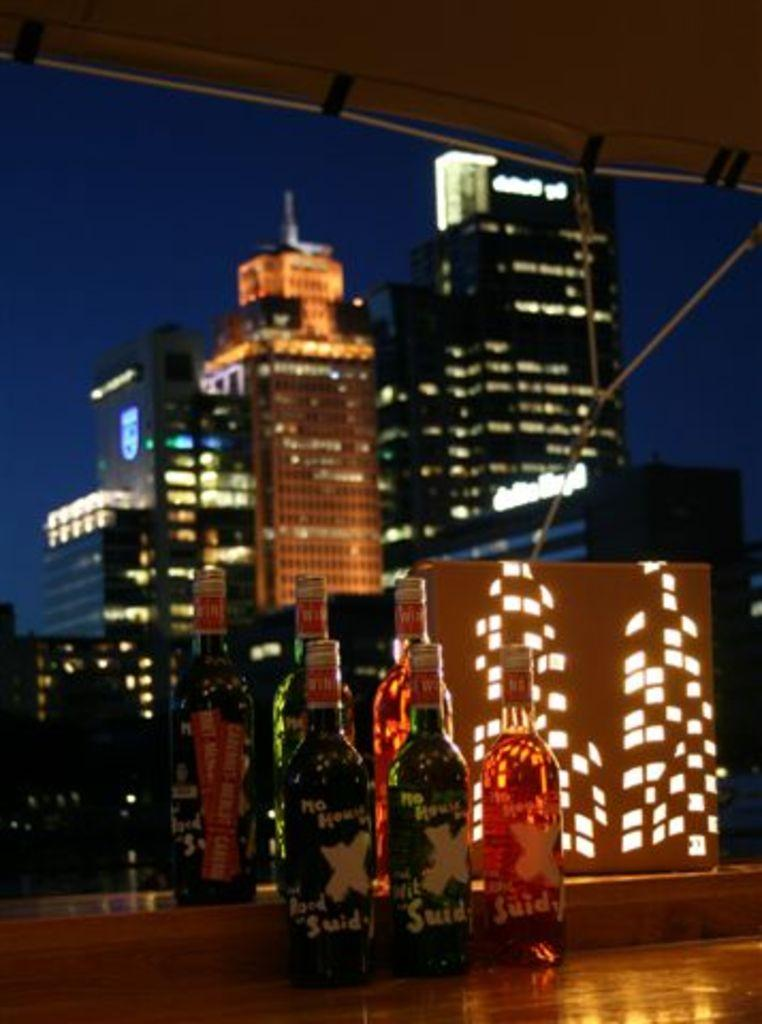<image>
Create a compact narrative representing the image presented. Some bottles with the letters SUID visible on the bottom. 